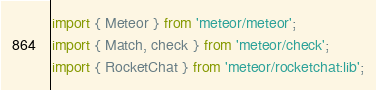Convert code to text. <code><loc_0><loc_0><loc_500><loc_500><_JavaScript_>import { Meteor } from 'meteor/meteor';
import { Match, check } from 'meteor/check';
import { RocketChat } from 'meteor/rocketchat:lib';
</code> 